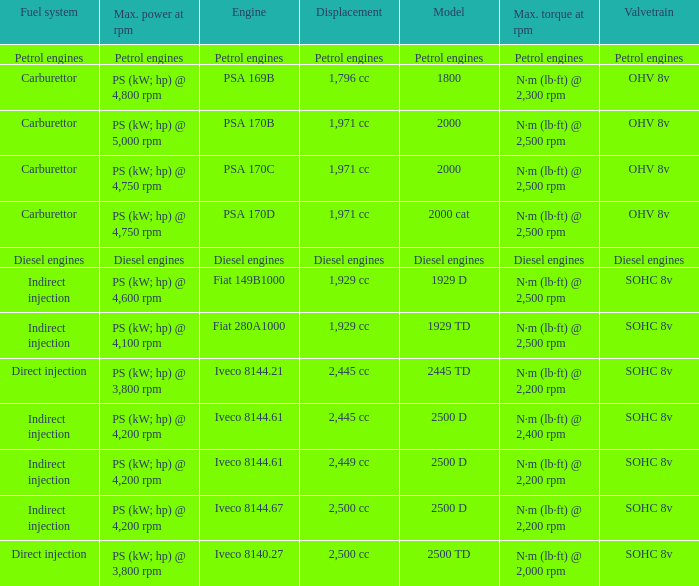What Valvetrain has a fuel system made up of petrol engines? Petrol engines. 